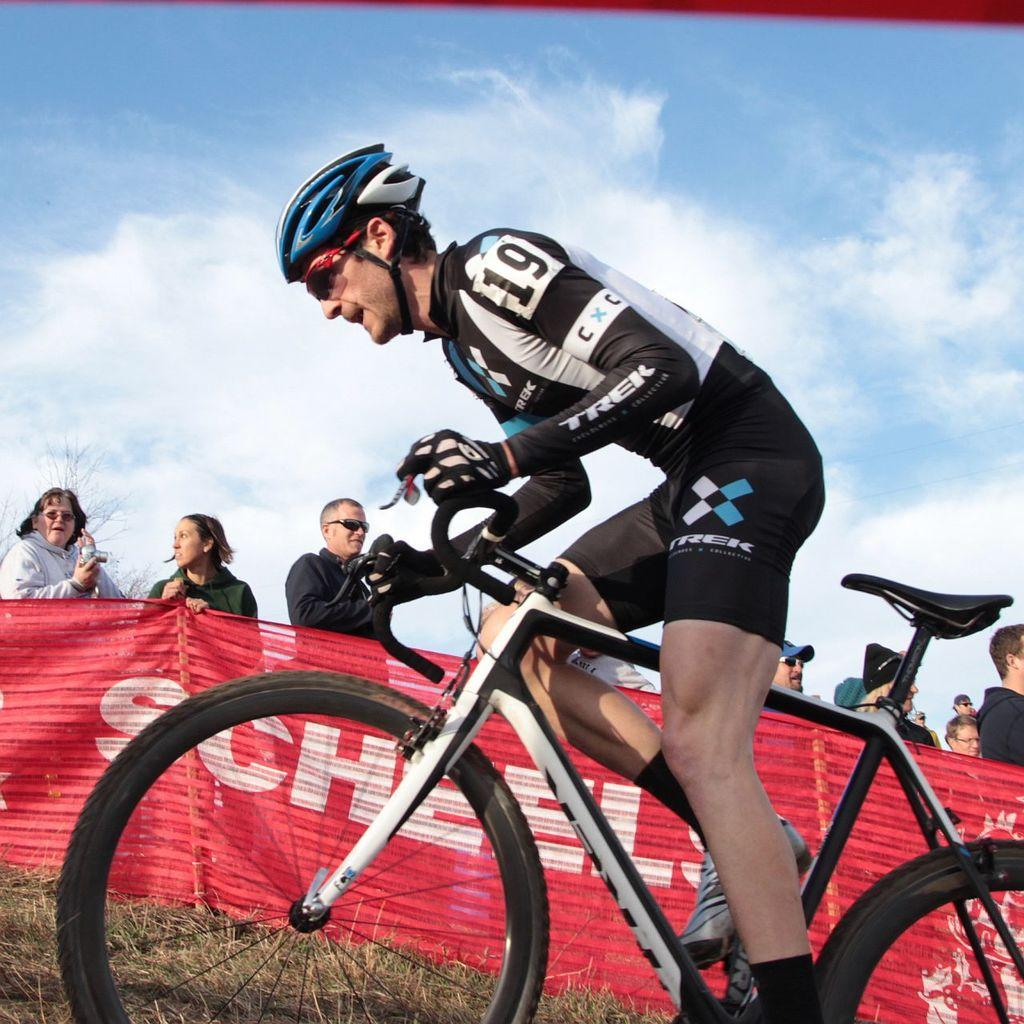What is the man in the image doing? The man is cycling in the image. What can be seen in the background of the image? There is a banner in the background of the image, and the sky is visible as well. What is written on the banner? There is text on the banner. Are there any people in the image besides the cyclist? Yes, there are people standing behind the banner. How many plants are being sold by the beggar in the image? There is no beggar or plants present in the image. 